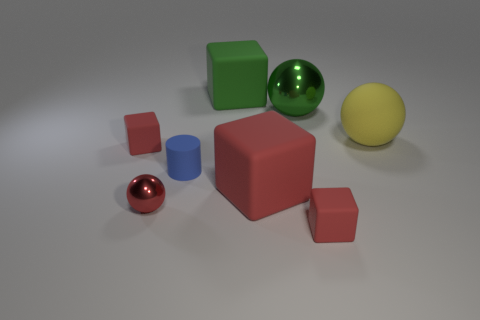What shape is the red metallic thing? sphere 